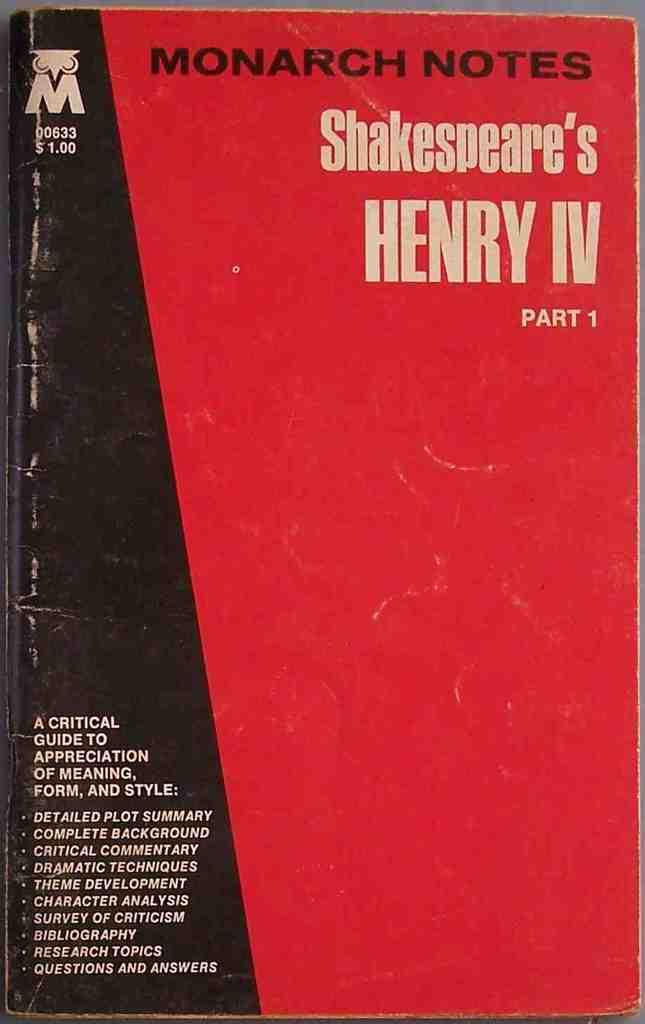<image>
Present a compact description of the photo's key features. A used copy of Monarch notes for Henry IV Part 1. 